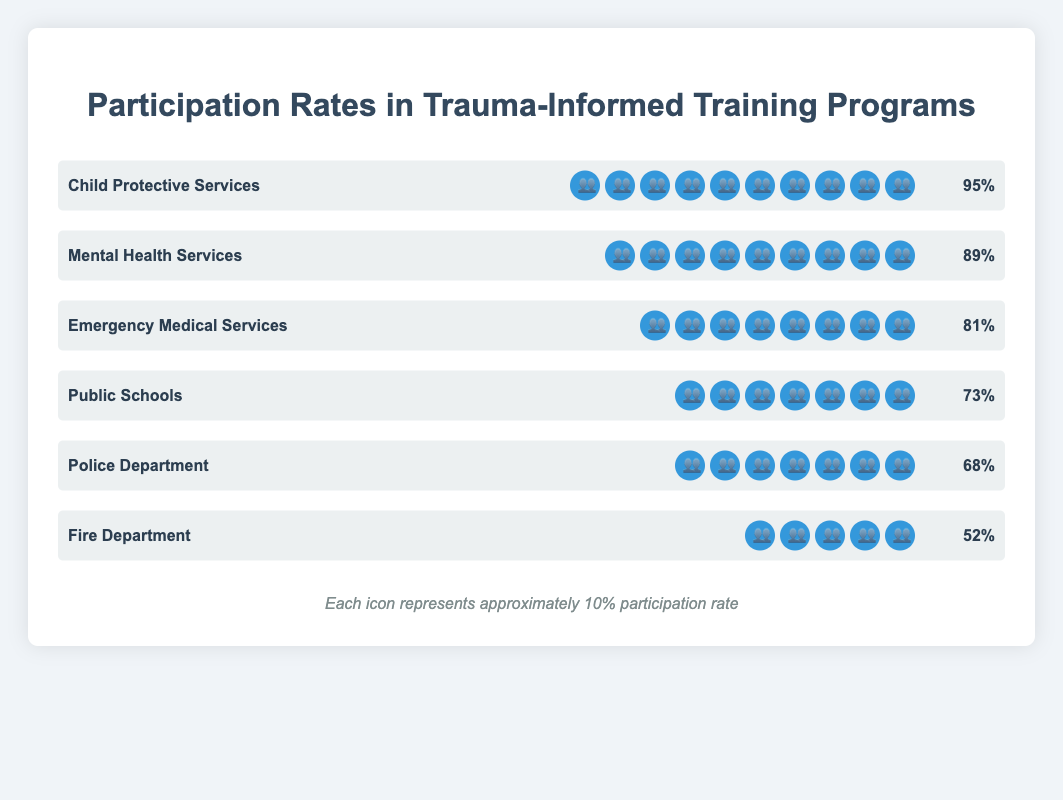Which department had the highest participation rate in trauma-informed training programs? According to the chart, Child Protective Services had 10 icons, representing a 95% participation rate, which is the highest among all the departments.
Answer: Child Protective Services What is the difference in participation rates between the Police Department and the Fire Department? The Police Department has a participation rate of 68%, while the Fire Department has a rate of 52%. The difference is calculated as 68% - 52% = 16%.
Answer: 16% Which two departments have participation rates closest to each other? By examining the participation rates, Public Schools at 73% and the Police Department at 68% have rates that are closest to each other, with a difference of 5%.
Answer: Public Schools and Police Department How many icons represent the participation rate for Emergency Medical Services? Each icon represents approximately 10% participation rate. Emergency Medical Services have a participation rate of 81%, thus represented by 8 icons.
Answer: 8 What is the average participation rate across all the departments? The participation rates for the departments are 68%, 52%, 81%, 95%, 73%, and 89%. Summing them up: 68 + 52 + 81 + 95 + 73 + 89 = 458. Dividing by the number of departments (6) gives 458 / 6 = 76.33%.
Answer: 76.33% Which department has the lowest participation rate, and by how much is it lower than the department with the highest rate? The Fire Department has the lowest participation rate at 52%. The highest rate is Child Protective Services at 95%. The difference is 95% - 52% = 43%.
Answer: Fire Department, 43% What is the combined participation rate for Public Schools and Mental Health Services? Public Schools have a participation rate of 73% and Mental Health Services have a rate of 89%. The combined rate is 73% + 89% = 162%.
Answer: 162% Compare the icons representing participation rates for Public Schools and the Police Department. Which department has more icons and by how many? Public Schools and the Police Department each have 7 icons representing their participation rates. The number of icons is the same for both departments.
Answer: The same, 0 How does the participation rate in trauma-informed training programs for Emergency Medical Services compare to that of the Public Schools? Emergency Medical Services have a participation rate of 81%, whereas Public Schools have 73%. Comparing these, 81% is greater than 73%.
Answer: Emergency Medical Services have a higher rate Which departments have participation rates above 80%? Departments with more than 8 icons (each icon represents 10%) are Child Protective Services (95%), Mental Health Services (89%), and Emergency Medical Services (81%).
Answer: Child Protective Services, Mental Health Services, Emergency Medical Services 